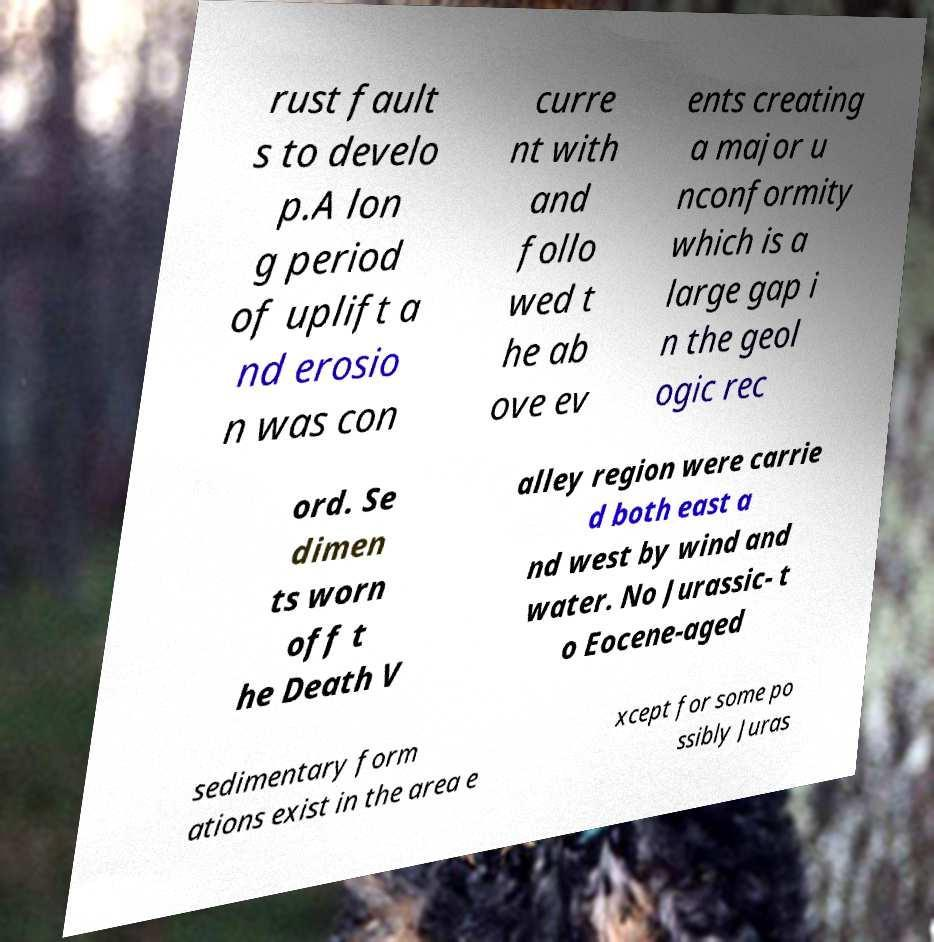Can you accurately transcribe the text from the provided image for me? rust fault s to develo p.A lon g period of uplift a nd erosio n was con curre nt with and follo wed t he ab ove ev ents creating a major u nconformity which is a large gap i n the geol ogic rec ord. Se dimen ts worn off t he Death V alley region were carrie d both east a nd west by wind and water. No Jurassic- t o Eocene-aged sedimentary form ations exist in the area e xcept for some po ssibly Juras 